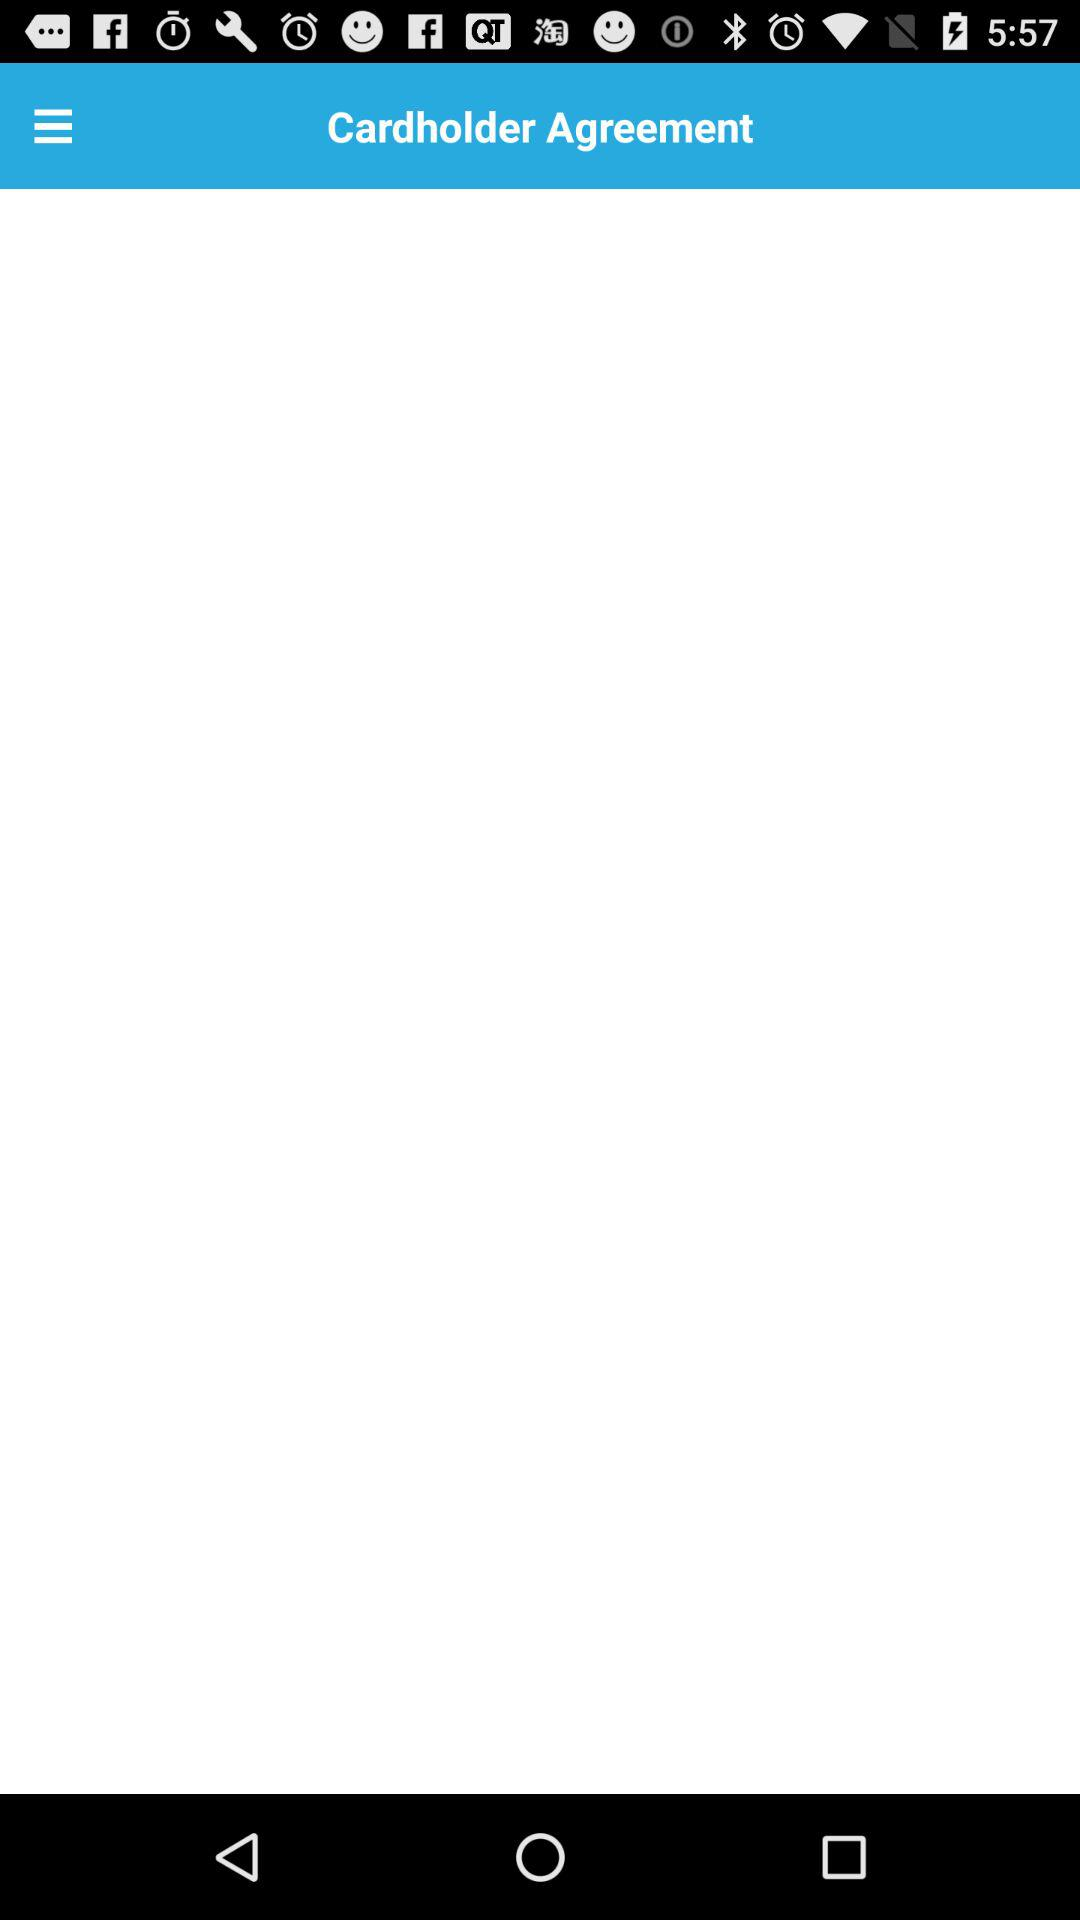What is the name of the agreement? The name of the agreement is "Cardholder Agreement". 